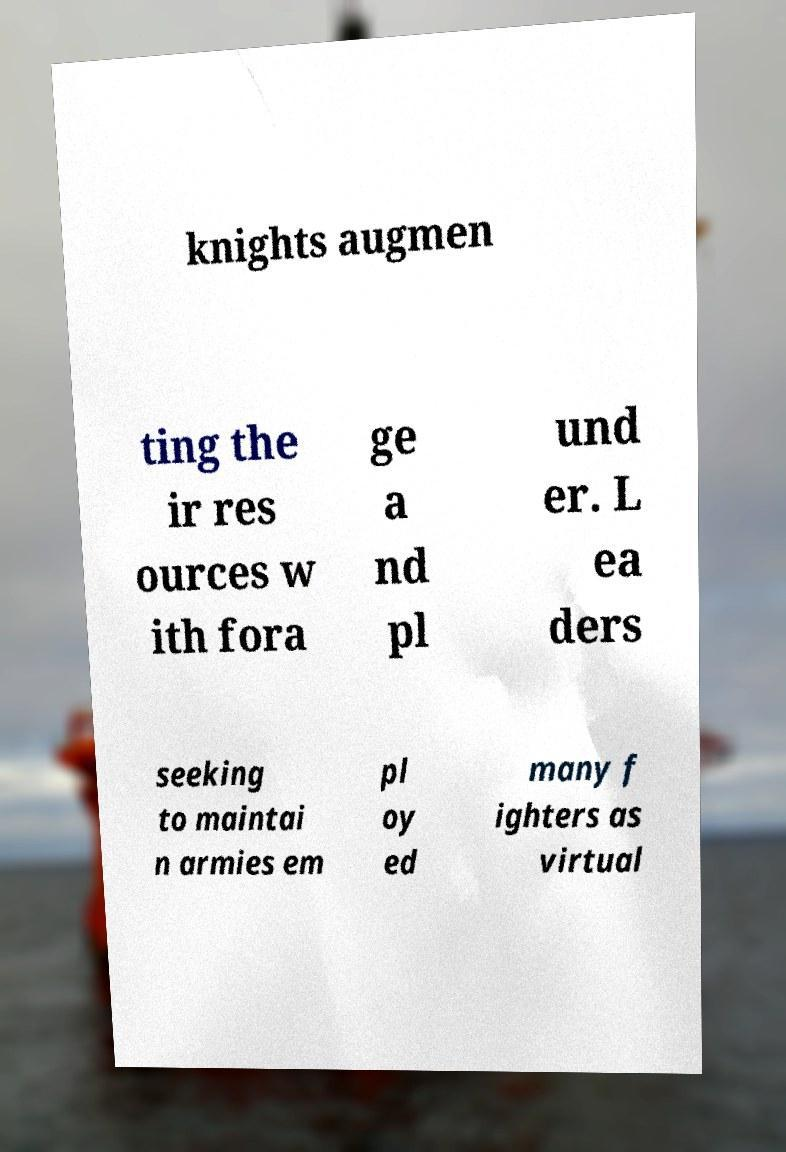Can you accurately transcribe the text from the provided image for me? knights augmen ting the ir res ources w ith fora ge a nd pl und er. L ea ders seeking to maintai n armies em pl oy ed many f ighters as virtual 